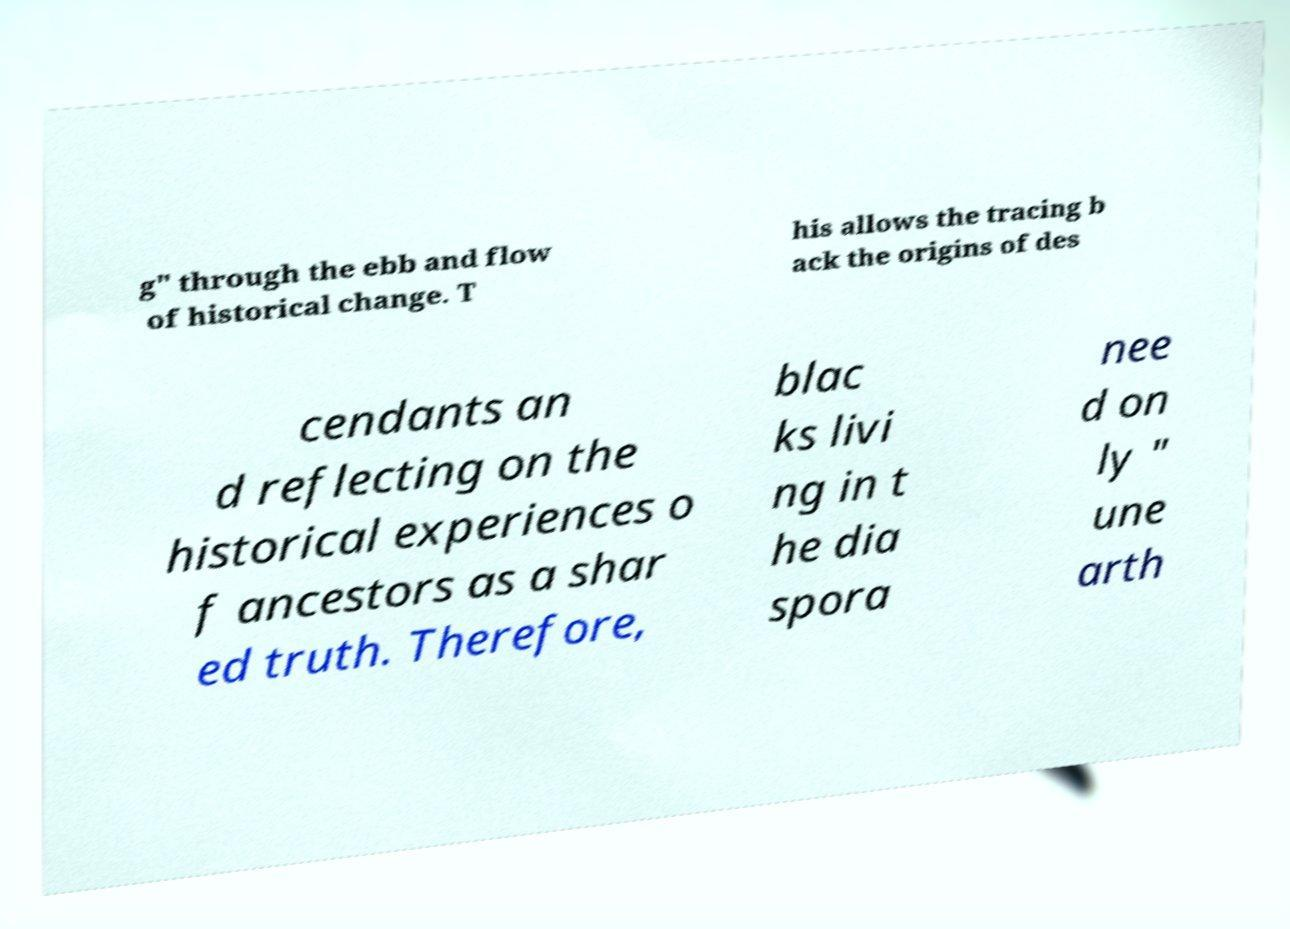Please identify and transcribe the text found in this image. g" through the ebb and flow of historical change. T his allows the tracing b ack the origins of des cendants an d reflecting on the historical experiences o f ancestors as a shar ed truth. Therefore, blac ks livi ng in t he dia spora nee d on ly " une arth 